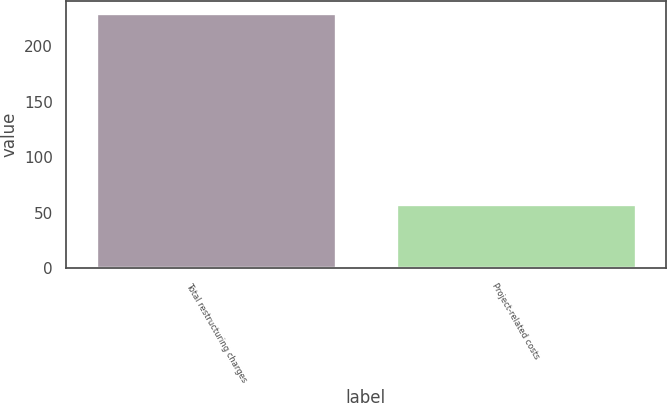Convert chart to OTSL. <chart><loc_0><loc_0><loc_500><loc_500><bar_chart><fcel>Total restructuring charges<fcel>Project-related costs<nl><fcel>229.8<fcel>57.5<nl></chart> 